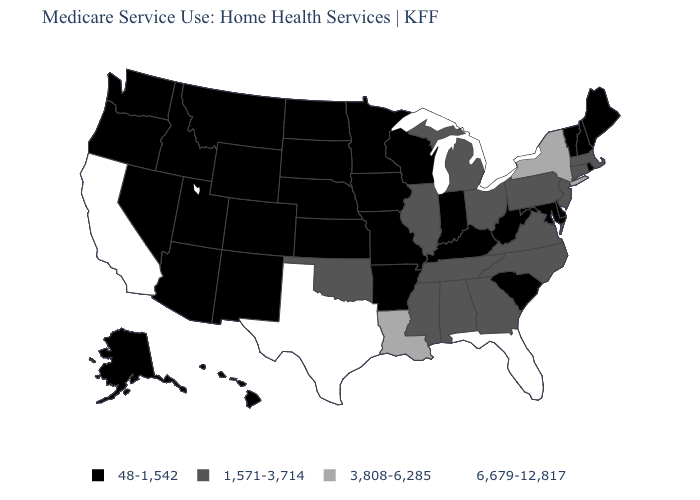Which states hav the highest value in the West?
Give a very brief answer. California. Which states have the lowest value in the USA?
Quick response, please. Alaska, Arizona, Arkansas, Colorado, Delaware, Hawaii, Idaho, Indiana, Iowa, Kansas, Kentucky, Maine, Maryland, Minnesota, Missouri, Montana, Nebraska, Nevada, New Hampshire, New Mexico, North Dakota, Oregon, Rhode Island, South Carolina, South Dakota, Utah, Vermont, Washington, West Virginia, Wisconsin, Wyoming. Name the states that have a value in the range 6,679-12,817?
Quick response, please. California, Florida, Texas. What is the value of Mississippi?
Give a very brief answer. 1,571-3,714. Which states hav the highest value in the Northeast?
Quick response, please. New York. What is the value of Texas?
Answer briefly. 6,679-12,817. Name the states that have a value in the range 1,571-3,714?
Write a very short answer. Alabama, Connecticut, Georgia, Illinois, Massachusetts, Michigan, Mississippi, New Jersey, North Carolina, Ohio, Oklahoma, Pennsylvania, Tennessee, Virginia. How many symbols are there in the legend?
Concise answer only. 4. Name the states that have a value in the range 48-1,542?
Concise answer only. Alaska, Arizona, Arkansas, Colorado, Delaware, Hawaii, Idaho, Indiana, Iowa, Kansas, Kentucky, Maine, Maryland, Minnesota, Missouri, Montana, Nebraska, Nevada, New Hampshire, New Mexico, North Dakota, Oregon, Rhode Island, South Carolina, South Dakota, Utah, Vermont, Washington, West Virginia, Wisconsin, Wyoming. Does South Carolina have the same value as Arizona?
Write a very short answer. Yes. Name the states that have a value in the range 6,679-12,817?
Keep it brief. California, Florida, Texas. What is the lowest value in states that border New Mexico?
Be succinct. 48-1,542. Does New York have the highest value in the Northeast?
Concise answer only. Yes. What is the value of Idaho?
Quick response, please. 48-1,542. What is the highest value in the USA?
Give a very brief answer. 6,679-12,817. 